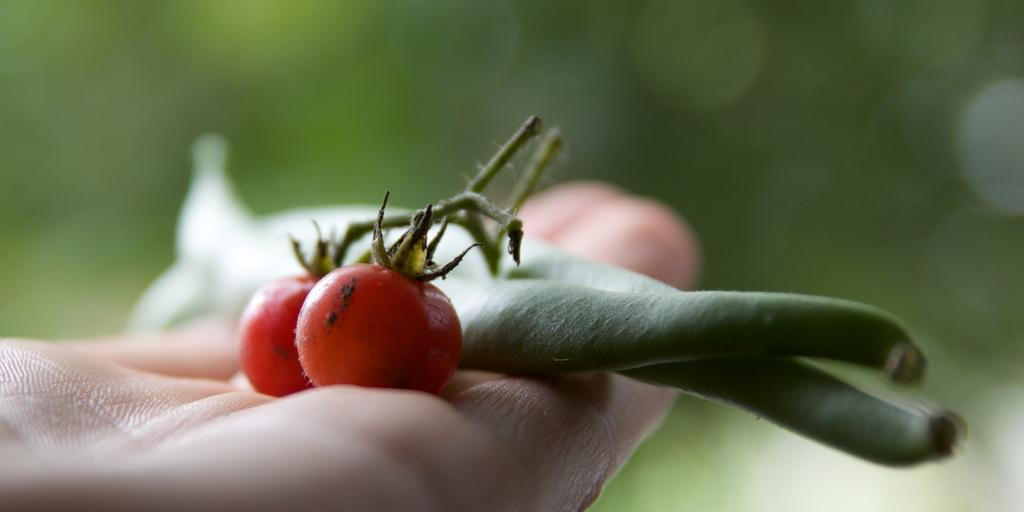What type of food items are present in the image? There are two tomatoes and other vegetables in the image. How are the tomatoes and vegetables positioned in the image? The tomatoes and vegetables are on a person's hand. What can be observed about the background of the image? The background of the image is blurry. How many toes can be seen on the person's hand in the image? There are no toes visible in the image, as the items are on a person's hand, not their foot. What type of screw is being used to hold the vegetables together in the image? There are no screws present in the image; the vegetables and tomatoes are simply on a person's hand. 